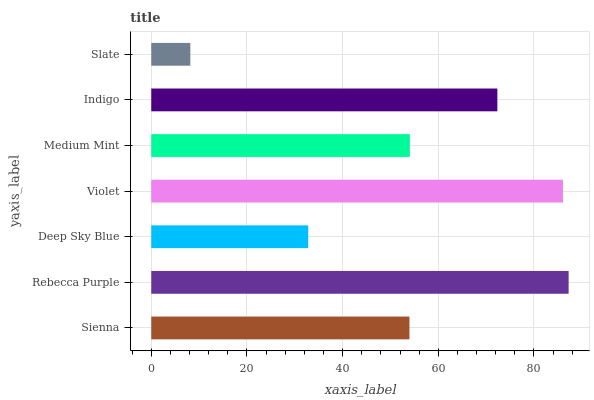Is Slate the minimum?
Answer yes or no. Yes. Is Rebecca Purple the maximum?
Answer yes or no. Yes. Is Deep Sky Blue the minimum?
Answer yes or no. No. Is Deep Sky Blue the maximum?
Answer yes or no. No. Is Rebecca Purple greater than Deep Sky Blue?
Answer yes or no. Yes. Is Deep Sky Blue less than Rebecca Purple?
Answer yes or no. Yes. Is Deep Sky Blue greater than Rebecca Purple?
Answer yes or no. No. Is Rebecca Purple less than Deep Sky Blue?
Answer yes or no. No. Is Medium Mint the high median?
Answer yes or no. Yes. Is Medium Mint the low median?
Answer yes or no. Yes. Is Indigo the high median?
Answer yes or no. No. Is Deep Sky Blue the low median?
Answer yes or no. No. 